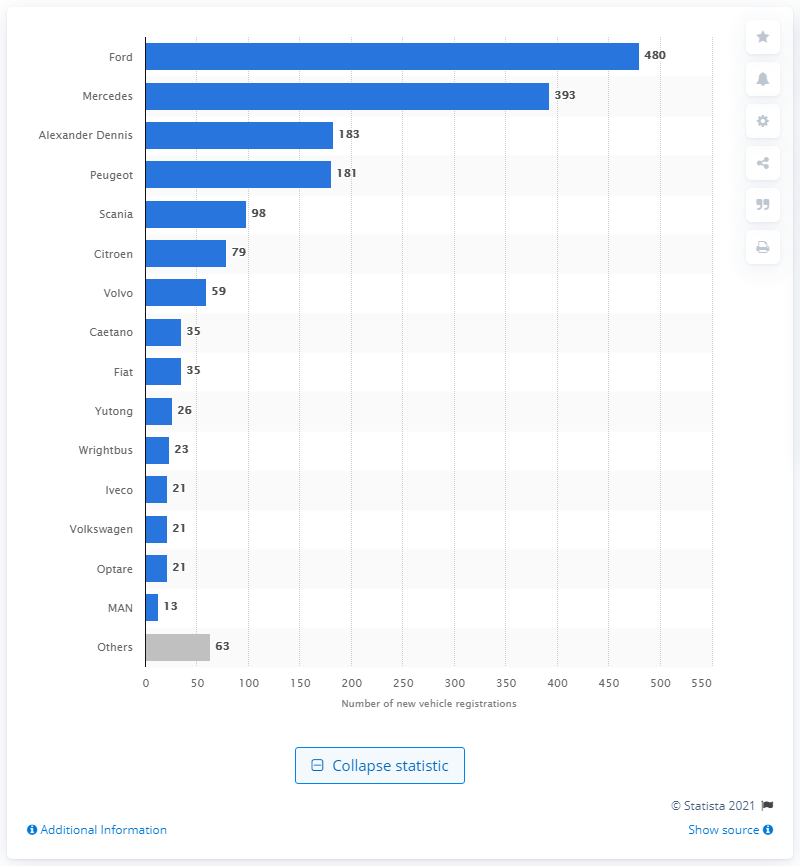Mention a couple of crucial points in this snapshot. In 2020, Ford sold 480 buses in the United Kingdom. In 2020, Alexander Dennis was the British bus building company. Based on the available information, it can be confidently stated that Ford was the leading bus and coach brand in the United Kingdom. 